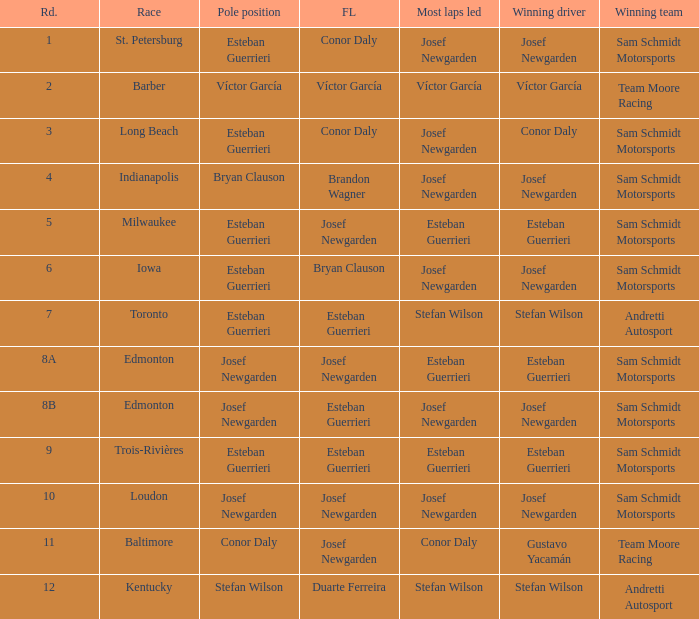What race did josef newgarden have the fastest lap and lead the most laps? Loudon. 